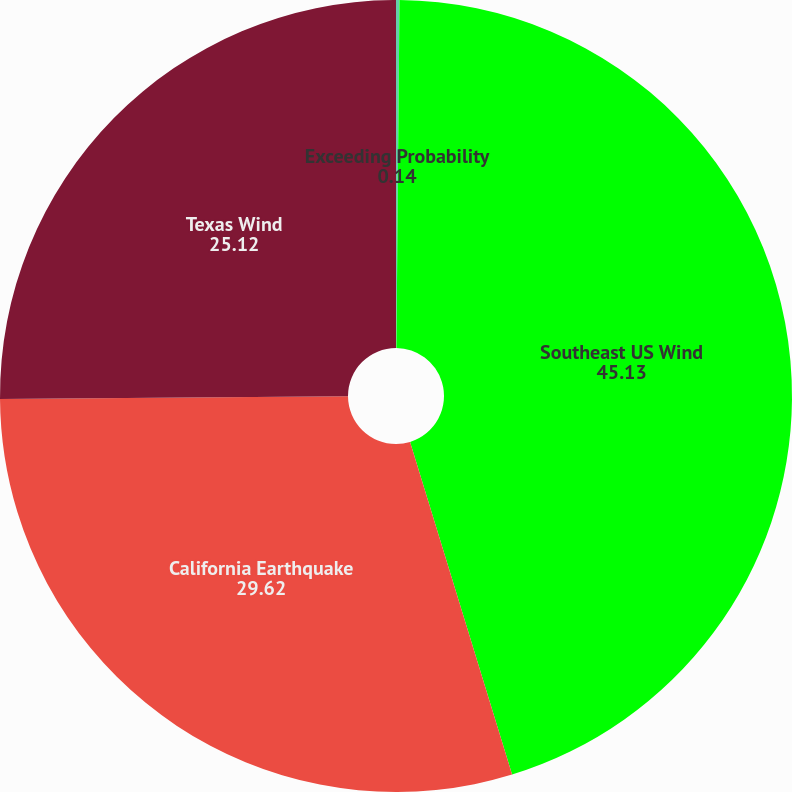Convert chart to OTSL. <chart><loc_0><loc_0><loc_500><loc_500><pie_chart><fcel>Exceeding Probability<fcel>Southeast US Wind<fcel>California Earthquake<fcel>Texas Wind<nl><fcel>0.14%<fcel>45.13%<fcel>29.62%<fcel>25.12%<nl></chart> 